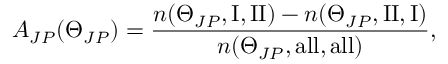Convert formula to latex. <formula><loc_0><loc_0><loc_500><loc_500>A _ { J P } ( \Theta _ { J P } ) = \frac { n ( \Theta _ { J P } , I , I I ) - n ( \Theta _ { J P } , I I , I ) } { n ( \Theta _ { J P } , a l l , a l l ) } ,</formula> 